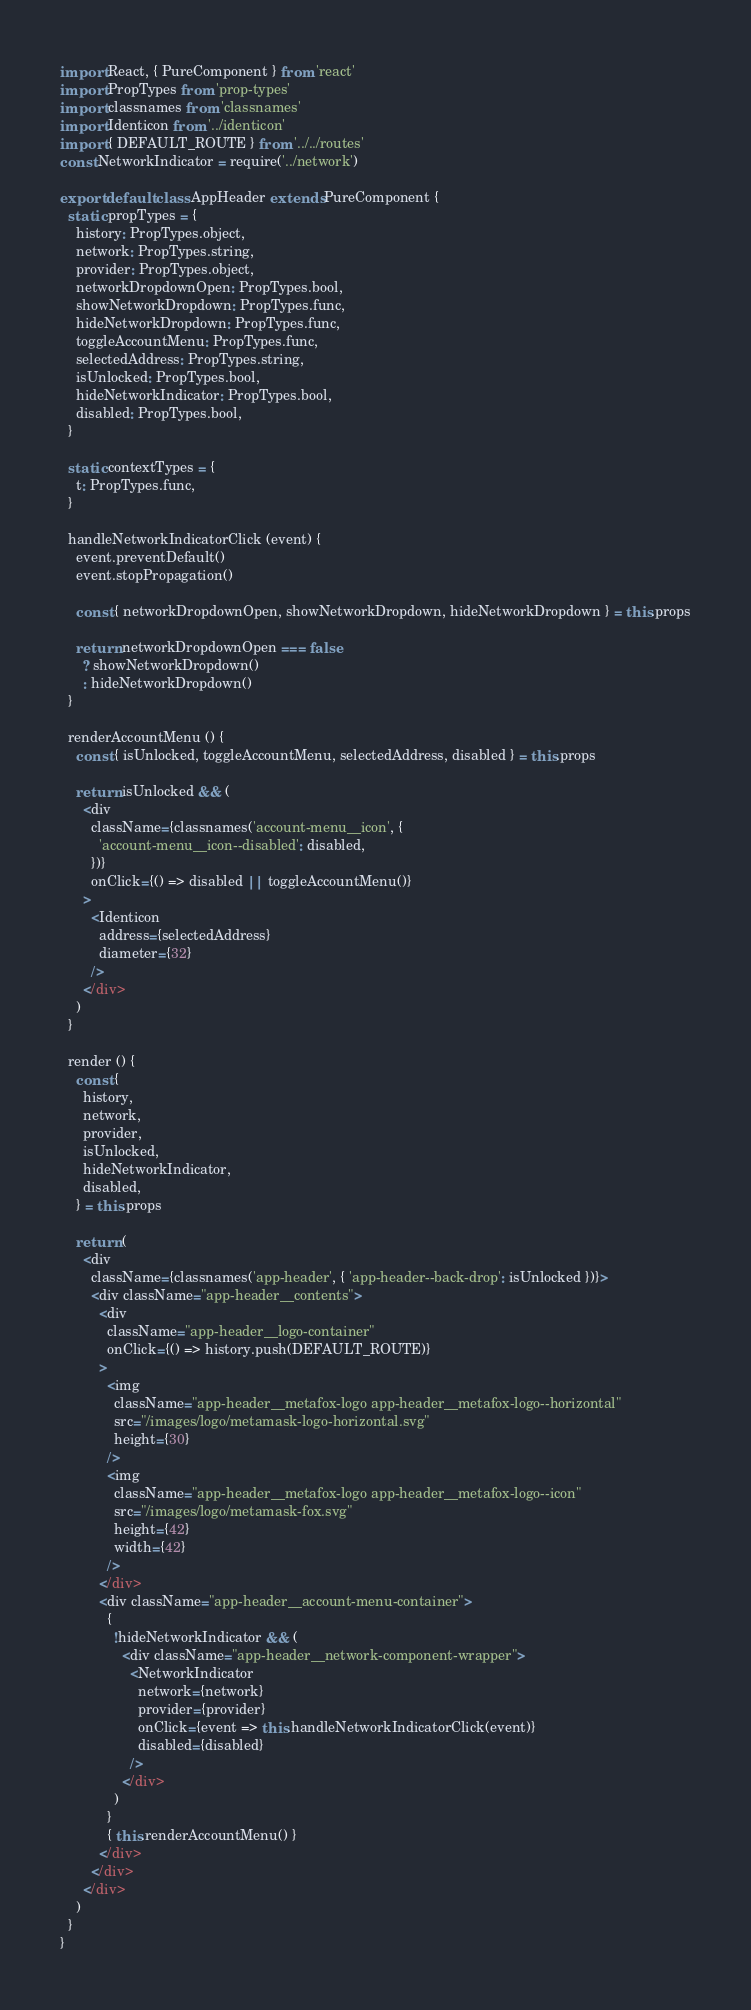<code> <loc_0><loc_0><loc_500><loc_500><_JavaScript_>import React, { PureComponent } from 'react'
import PropTypes from 'prop-types'
import classnames from 'classnames'
import Identicon from '../identicon'
import { DEFAULT_ROUTE } from '../../routes'
const NetworkIndicator = require('../network')

export default class AppHeader extends PureComponent {
  static propTypes = {
    history: PropTypes.object,
    network: PropTypes.string,
    provider: PropTypes.object,
    networkDropdownOpen: PropTypes.bool,
    showNetworkDropdown: PropTypes.func,
    hideNetworkDropdown: PropTypes.func,
    toggleAccountMenu: PropTypes.func,
    selectedAddress: PropTypes.string,
    isUnlocked: PropTypes.bool,
    hideNetworkIndicator: PropTypes.bool,
    disabled: PropTypes.bool,
  }

  static contextTypes = {
    t: PropTypes.func,
  }

  handleNetworkIndicatorClick (event) {
    event.preventDefault()
    event.stopPropagation()

    const { networkDropdownOpen, showNetworkDropdown, hideNetworkDropdown } = this.props

    return networkDropdownOpen === false
      ? showNetworkDropdown()
      : hideNetworkDropdown()
  }

  renderAccountMenu () {
    const { isUnlocked, toggleAccountMenu, selectedAddress, disabled } = this.props

    return isUnlocked && (
      <div
        className={classnames('account-menu__icon', {
          'account-menu__icon--disabled': disabled,
        })}
        onClick={() => disabled || toggleAccountMenu()}
      >
        <Identicon
          address={selectedAddress}
          diameter={32}
        />
      </div>
    )
  }

  render () {
    const {
      history,
      network,
      provider,
      isUnlocked,
      hideNetworkIndicator,
      disabled,
    } = this.props

    return (
      <div
        className={classnames('app-header', { 'app-header--back-drop': isUnlocked })}>
        <div className="app-header__contents">
          <div
            className="app-header__logo-container"
            onClick={() => history.push(DEFAULT_ROUTE)}
          >
            <img
              className="app-header__metafox-logo app-header__metafox-logo--horizontal"
              src="/images/logo/metamask-logo-horizontal.svg"
              height={30}
            />
            <img
              className="app-header__metafox-logo app-header__metafox-logo--icon"
              src="/images/logo/metamask-fox.svg"
              height={42}
              width={42}
            />
          </div>
          <div className="app-header__account-menu-container">
            {
              !hideNetworkIndicator && (
                <div className="app-header__network-component-wrapper">
                  <NetworkIndicator
                    network={network}
                    provider={provider}
                    onClick={event => this.handleNetworkIndicatorClick(event)}
                    disabled={disabled}
                  />
                </div>
              )
            }
            { this.renderAccountMenu() }
          </div>
        </div>
      </div>
    )
  }
}
</code> 